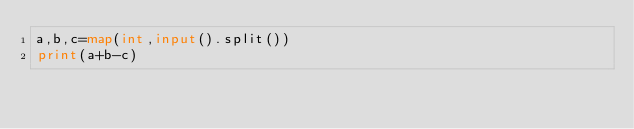Convert code to text. <code><loc_0><loc_0><loc_500><loc_500><_Python_>a,b,c=map(int,input().split())
print(a+b-c)</code> 